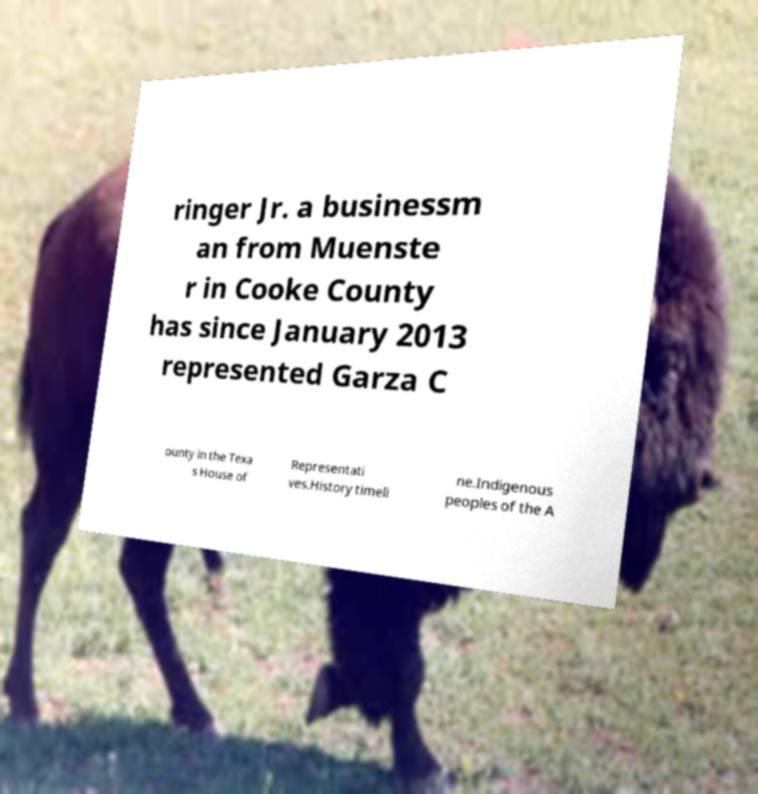Please read and relay the text visible in this image. What does it say? ringer Jr. a businessm an from Muenste r in Cooke County has since January 2013 represented Garza C ounty in the Texa s House of Representati ves.History timeli ne.Indigenous peoples of the A 